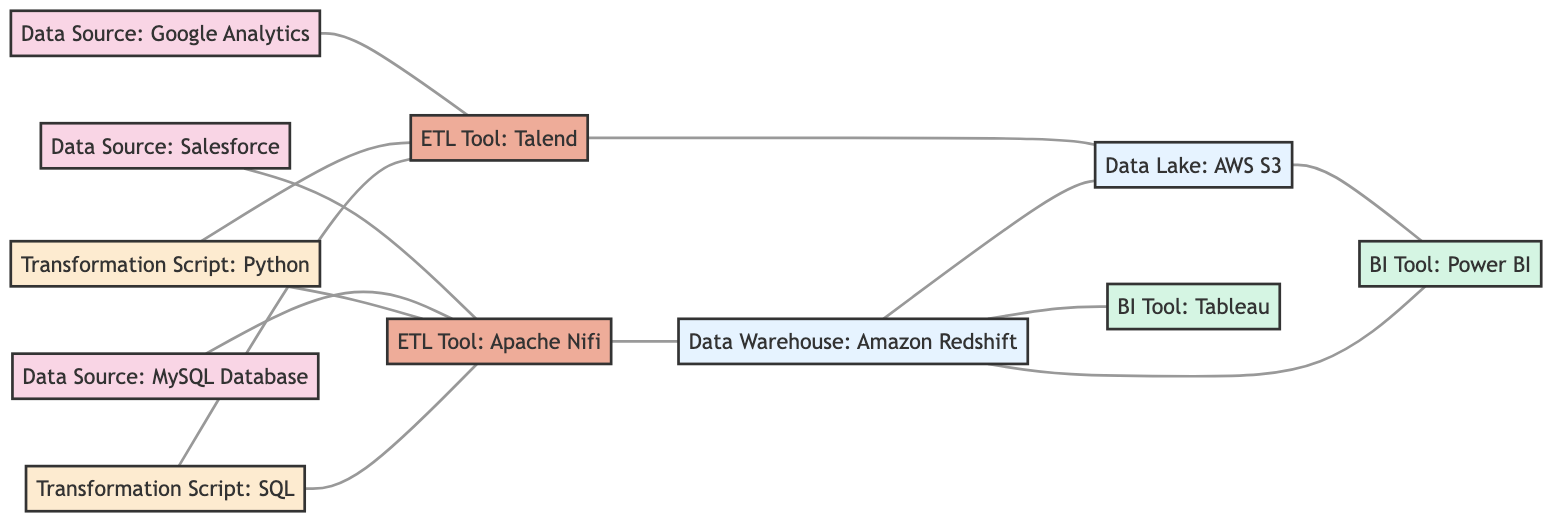What is the total number of nodes in the diagram? The diagram has 11 distinct nodes; they are the various data sources, ETL tools, data stores, transformation scripts, and BI tools listed.
Answer: 11 Which ETL tool is directly connected to the Salesforce data source? The edge between node 1 ("Data Source: Salesforce") and node 4 ("ETL Tool: Apache Nifi") indicates that Apache Nifi is directly connected to the Salesforce data source.
Answer: Apache Nifi How many edges connect directly to the Data Warehouse? The Data Warehouse ("Amazon Redshift") node (node 6) has 3 direct connections as indicated by edges: one from Apache Nifi, one from AWS S3, and another leading to Tableau and Power BI.
Answer: 3 Which transformation script is associated with both ETL tools in the diagram? Both ETL tools (Apache Nifi and Talend) are connected by edges to the transformation script labeled "Python" (node 10), indicating its association with both tools.
Answer: Python Is there a direct connection between Google Analytics and Tableau? The diagram does not show a direct edge between the Google Analytics node (node 2) and the Tableau node (node 8), indicating they are not directly connected.
Answer: No Which data store is connected to both a Data Warehouse and a Data Lake? The Amazon Redshift (Data Warehouse) and AWS S3 (Data Lake) nodes are both connected through edges, indicating connectivity between these two data stores.
Answer: AWS S3 What is the relationship between the MySQL Database and ETL tools? The MySQL Database (node 3) is connected directly to Apache Nifi (node 4) via an edge, indicating a dependency on this ETL tool.
Answer: Apache Nifi Which BI Tool has a connection to the Data Warehouse? Tableau (node 8) and Power BI (node 9) both connect to the Data Warehouse (node 6), indicating they can utilize data processed and stored there.
Answer: Tableau and Power BI How many transformation scripts are connected to the ETL Tool: Talend? Two transformation scripts, Python (node 10) and SQL (node 11), are connected to Talend (node 5) through edges, indicating their relation to this ETL tool.
Answer: 2 